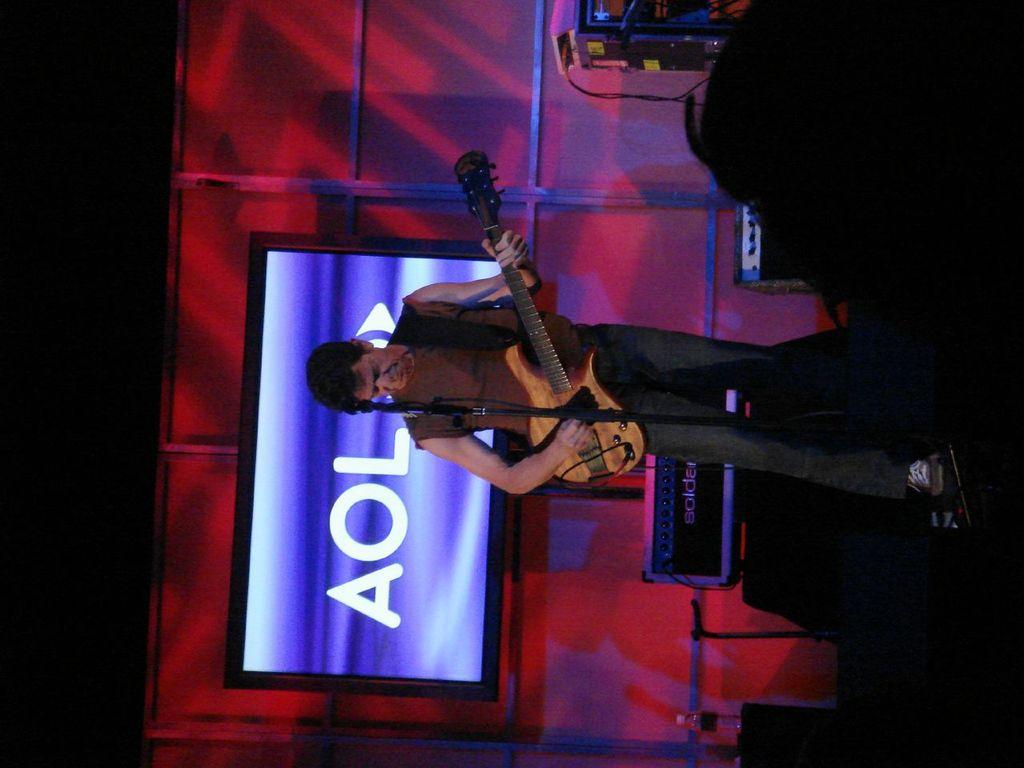What is the man in the image doing? The man is playing a guitar. Where is the man positioned in relation to the microphone? The man is in front of a microphone. What additional feature can be seen in the image? There is a digital display visible in the image. What type of frame is around the window in the image? There is no window present in the image; it only features a man playing a guitar, a microphone, and a digital display. 